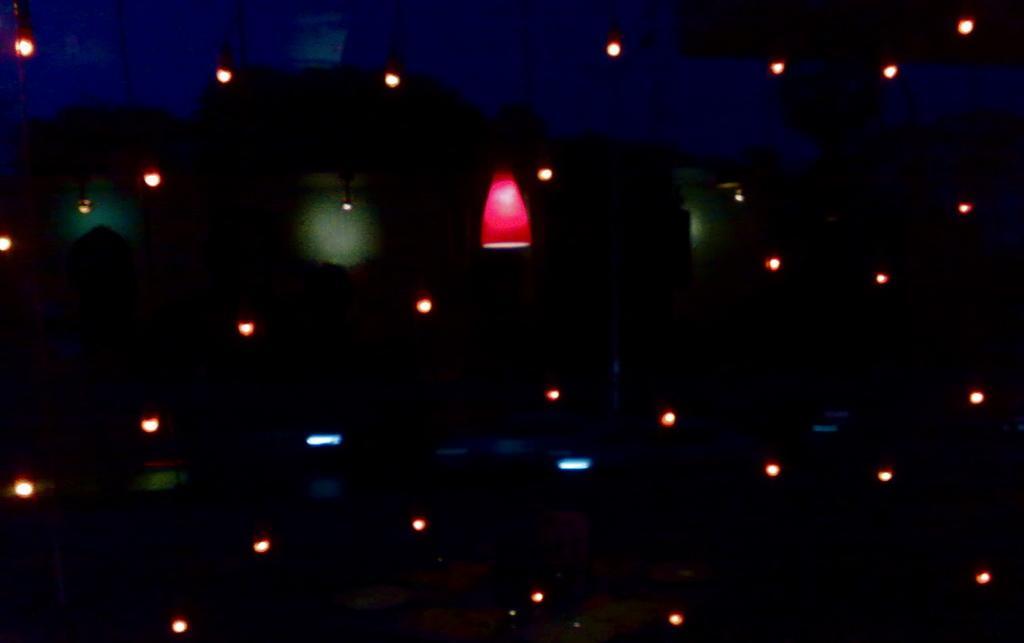Describe this image in one or two sentences. In this image we can see lights. 